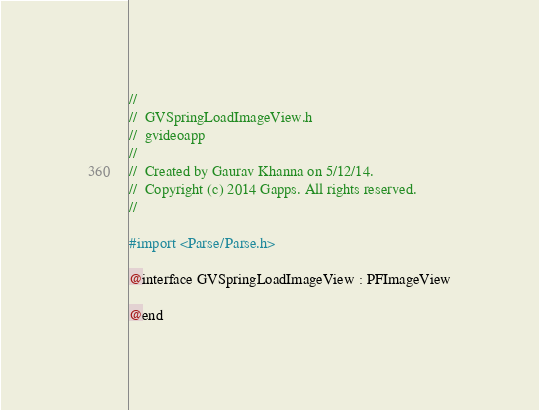Convert code to text. <code><loc_0><loc_0><loc_500><loc_500><_C_>//
//  GVSpringLoadImageView.h
//  gvideoapp
//
//  Created by Gaurav Khanna on 5/12/14.
//  Copyright (c) 2014 Gapps. All rights reserved.
//

#import <Parse/Parse.h>

@interface GVSpringLoadImageView : PFImageView

@end
</code> 